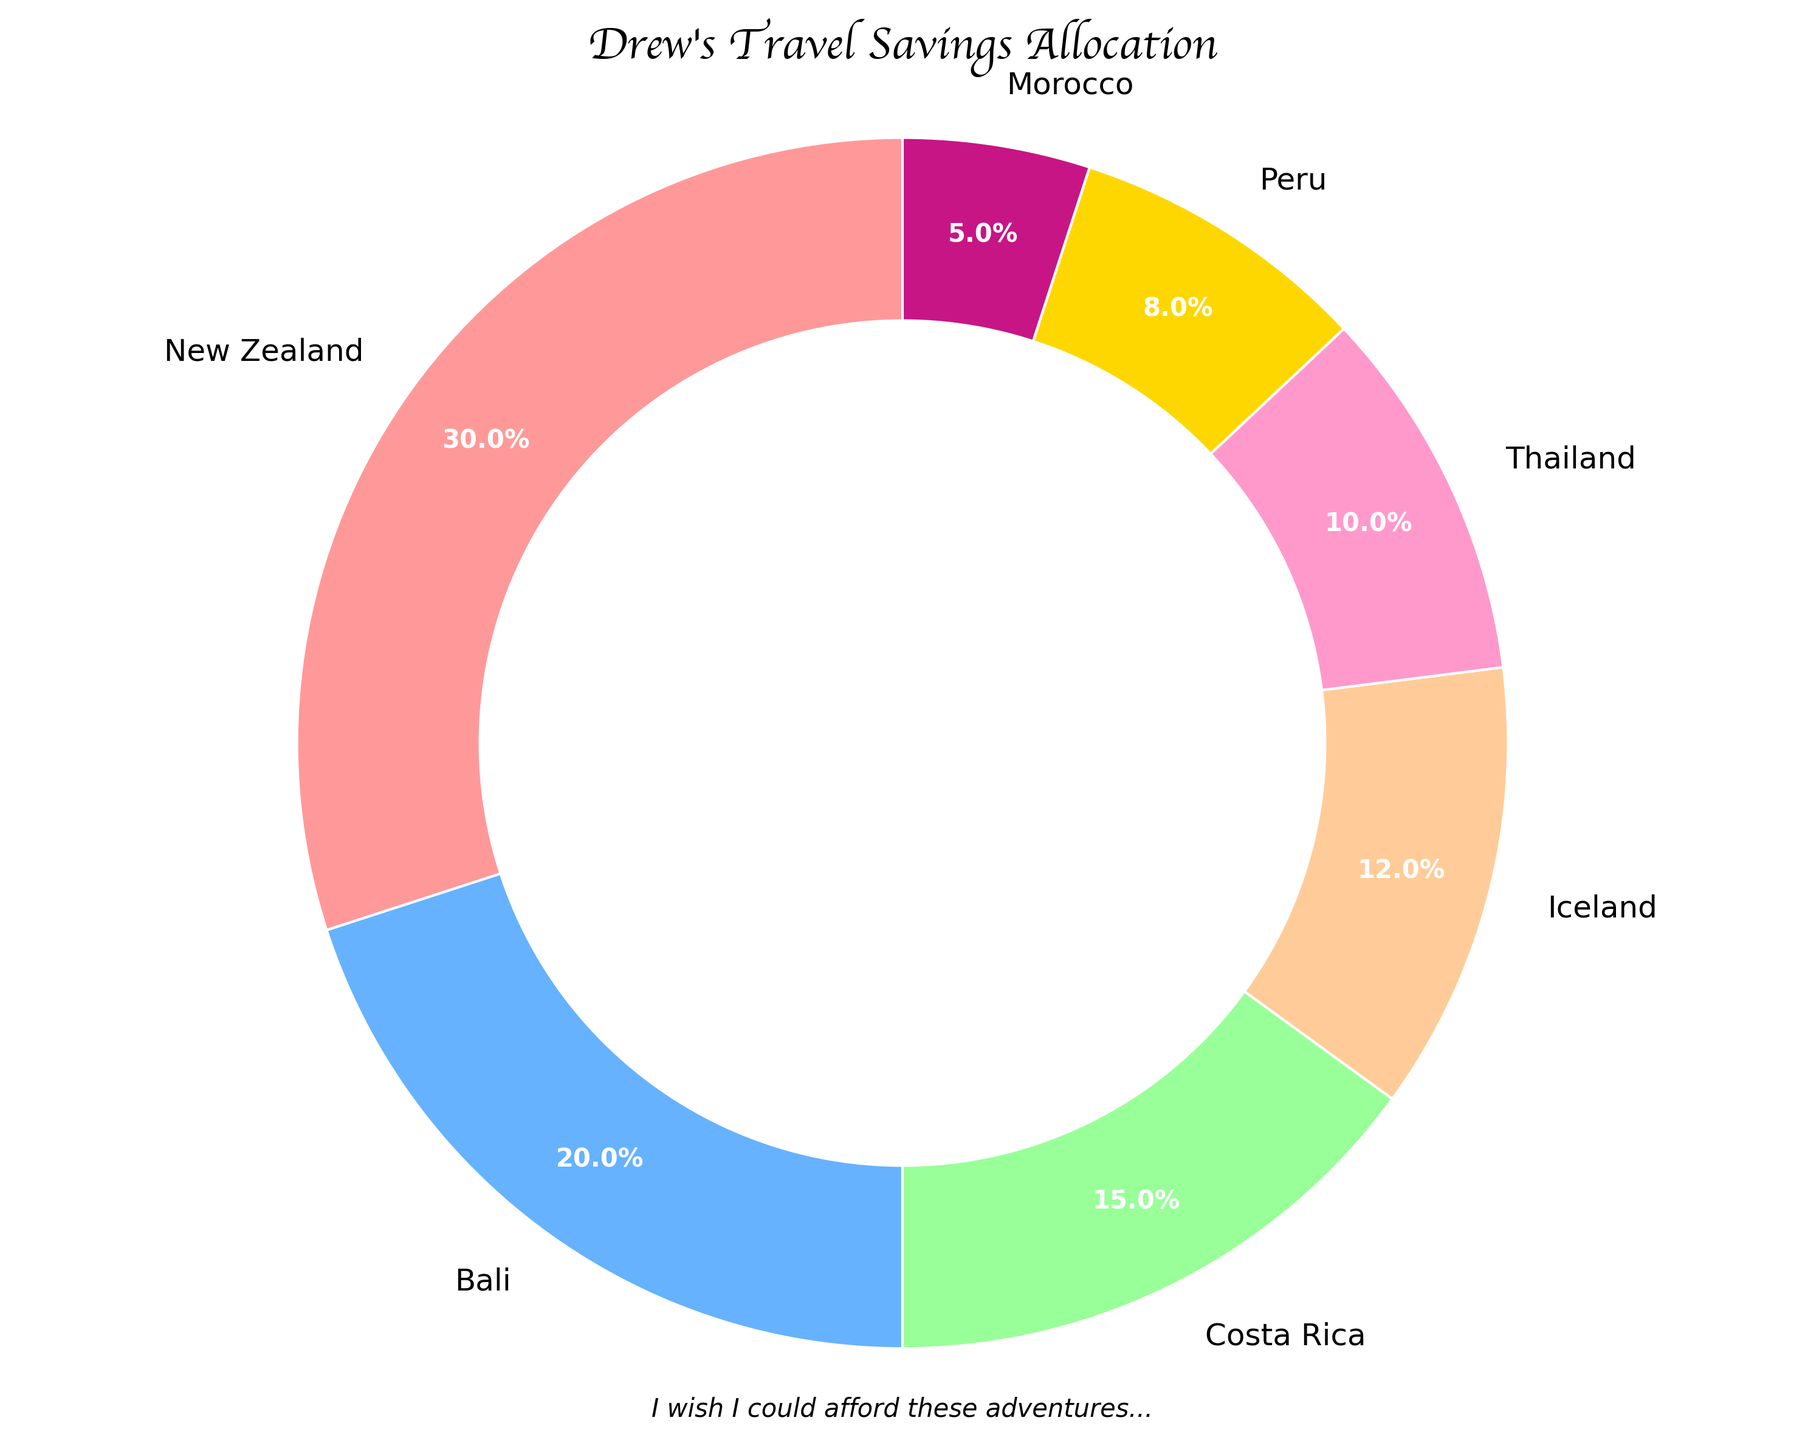What's the largest allocation in Drew's travel savings? The largest allocation is represented by the largest wedge in the pie chart. This is for New Zealand at 30%.
Answer: New Zealand Which destination has the smallest allocation? The smallest wedge in the pie chart is for Morocco, which has an allocation of 5%.
Answer: Morocco What is the combined savings allocation for Costa Rica, Iceland, and Thailand? The percentages for Costa Rica, Iceland, and Thailand are 15%, 12%, and 10% respectively. Adding these together gives: 15 + 12 + 10 = 37%.
Answer: 37% How much more savings allocation does New Zealand have compared to Peru? New Zealand's allocation is 30% and Peru's is 8%. The difference is 30 - 8 = 22%.
Answer: 22% Is Bali's savings allocation greater than or less than Costa Rica's? Bali's allocation is 20%, while Costa Rica's is 15%. Since 20% > 15%, Bali's savings allocation is greater.
Answer: Greater What is the average savings allocation for the destinations listed? The total allocation is 100%, and there are 7 destinations. Dividing the total by the number of destinations gives: 100 / 7 ≈ 14.29%.
Answer: 14.29% What color represents the allocation for Iceland? The pie chart colors are unique for each destination. Iceland is the fourth destination in the list and is represented by the fourth color. On the pie chart, it's the light brown wedge.
Answer: Light brown What is the percentage difference between the allocations for Bali and Thailand? Bali's allocation is 20% and Thailand's is 10%. The difference is 20 - 10 = 10%.
Answer: 10% Which destinations have allocations exceeding 10%? From the pie chart, New Zealand (30%), Bali (20%), Costa Rica (15%), and Iceland (12%) have allocations exceeding 10%.
Answer: New Zealand, Bali, Costa Rica, Iceland Is the sum of the allocations for Peru and Morocco greater than Iceland's allocation? Peru's allocation is 8% and Morocco's is 5%. Their sum is 8 + 5 = 13%, which is greater than Iceland's 12%.
Answer: Yes 